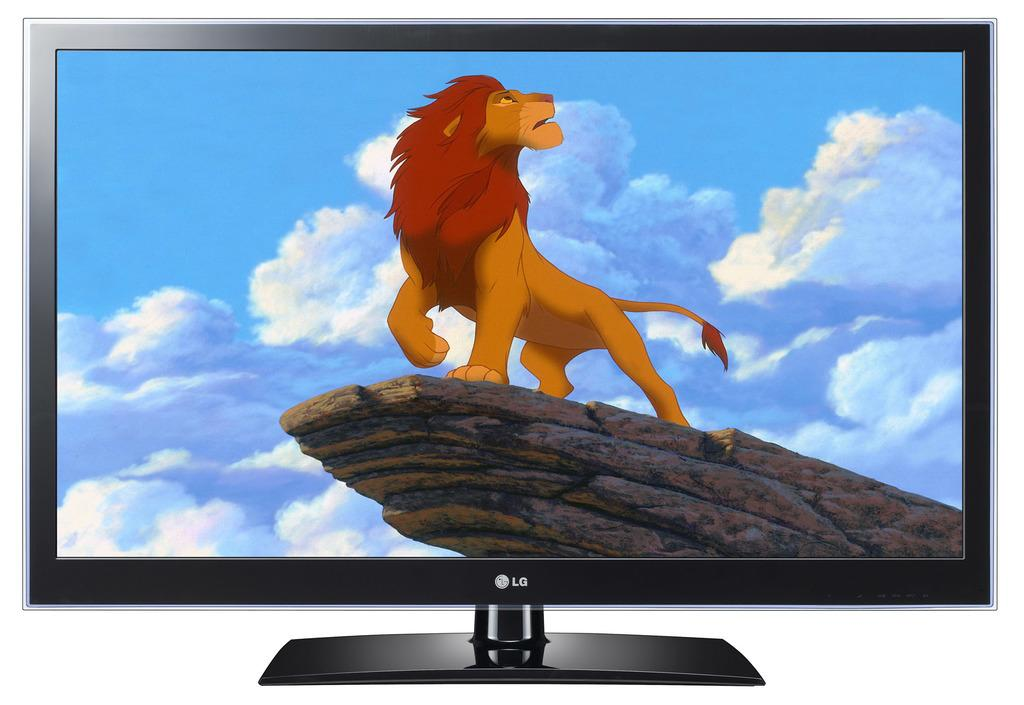Provide a one-sentence caption for the provided image. A black flat panel television with a cartoon lion on screen. 